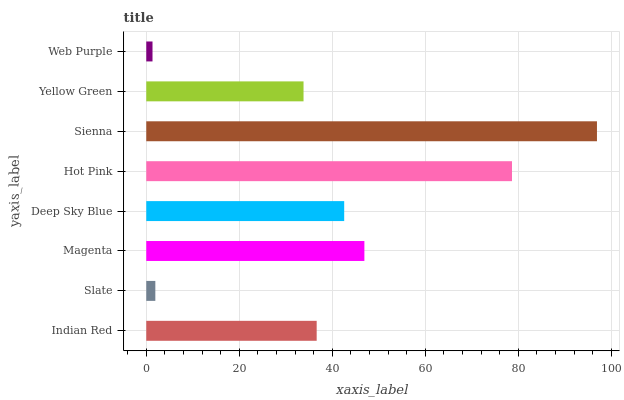Is Web Purple the minimum?
Answer yes or no. Yes. Is Sienna the maximum?
Answer yes or no. Yes. Is Slate the minimum?
Answer yes or no. No. Is Slate the maximum?
Answer yes or no. No. Is Indian Red greater than Slate?
Answer yes or no. Yes. Is Slate less than Indian Red?
Answer yes or no. Yes. Is Slate greater than Indian Red?
Answer yes or no. No. Is Indian Red less than Slate?
Answer yes or no. No. Is Deep Sky Blue the high median?
Answer yes or no. Yes. Is Indian Red the low median?
Answer yes or no. Yes. Is Web Purple the high median?
Answer yes or no. No. Is Deep Sky Blue the low median?
Answer yes or no. No. 